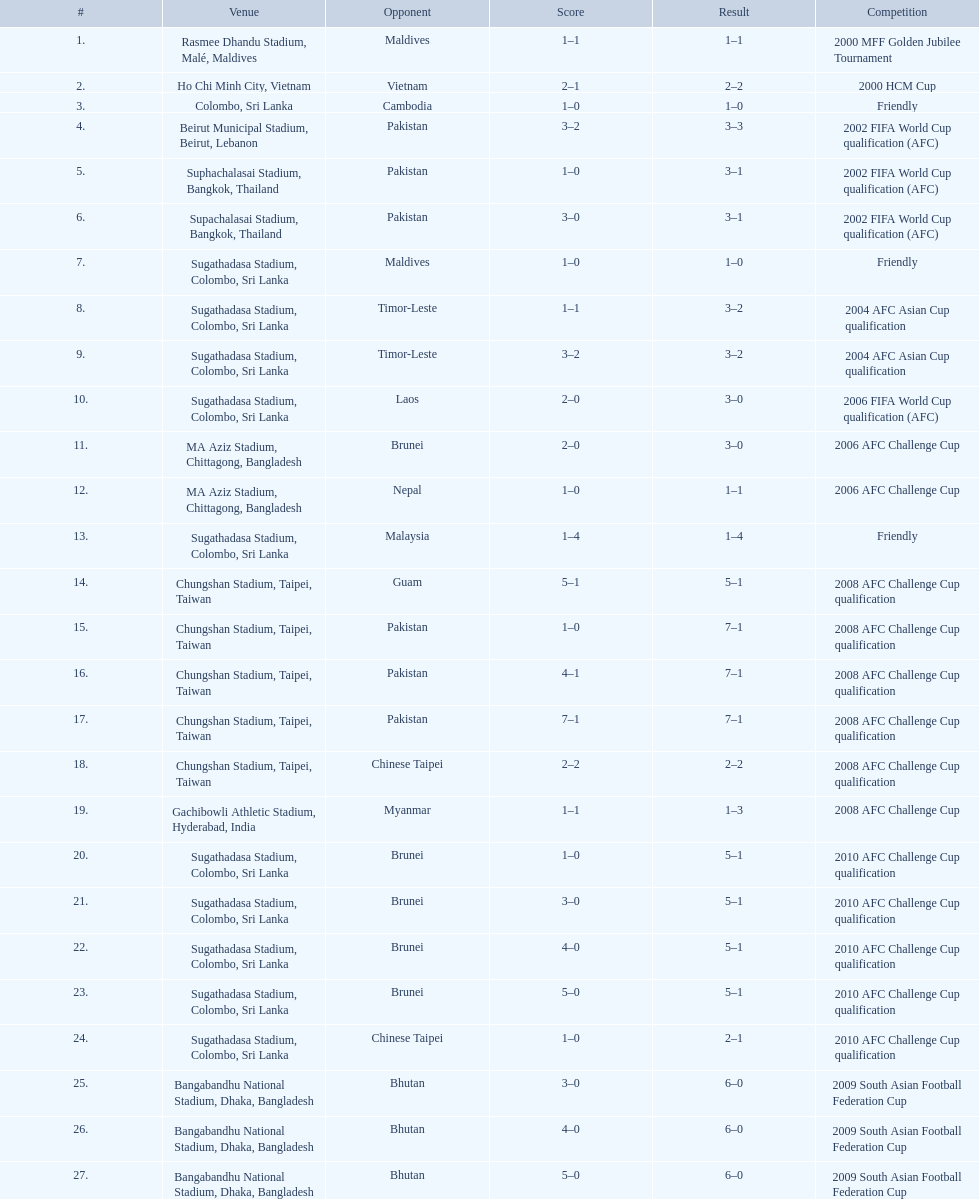Which team did this player face before pakistan on april 4, 2008? Guam. 